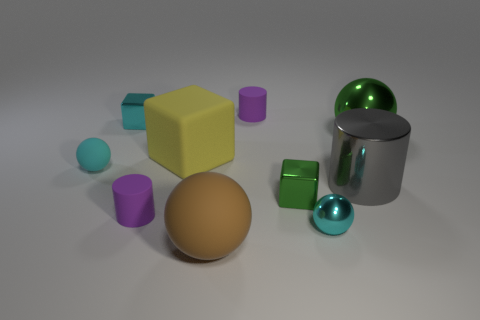Is the yellow block made of the same material as the big brown ball?
Your answer should be compact. Yes. What number of spheres are big shiny objects or purple things?
Your response must be concise. 1. There is a matte cylinder behind the large yellow matte thing; what color is it?
Make the answer very short. Purple. What number of rubber things are either big green spheres or gray objects?
Provide a short and direct response. 0. There is a big sphere left of the tiny sphere that is to the right of the cyan rubber object; what is it made of?
Offer a very short reply. Rubber. There is a tiny cube that is the same color as the tiny rubber ball; what material is it?
Your answer should be very brief. Metal. What color is the tiny metallic ball?
Provide a succinct answer. Cyan. There is a metal thing that is behind the big shiny sphere; are there any gray cylinders that are to the right of it?
Your answer should be compact. Yes. What material is the large yellow object?
Give a very brief answer. Rubber. Do the small cube that is on the left side of the brown matte object and the large ball that is behind the big gray object have the same material?
Your answer should be compact. Yes. 